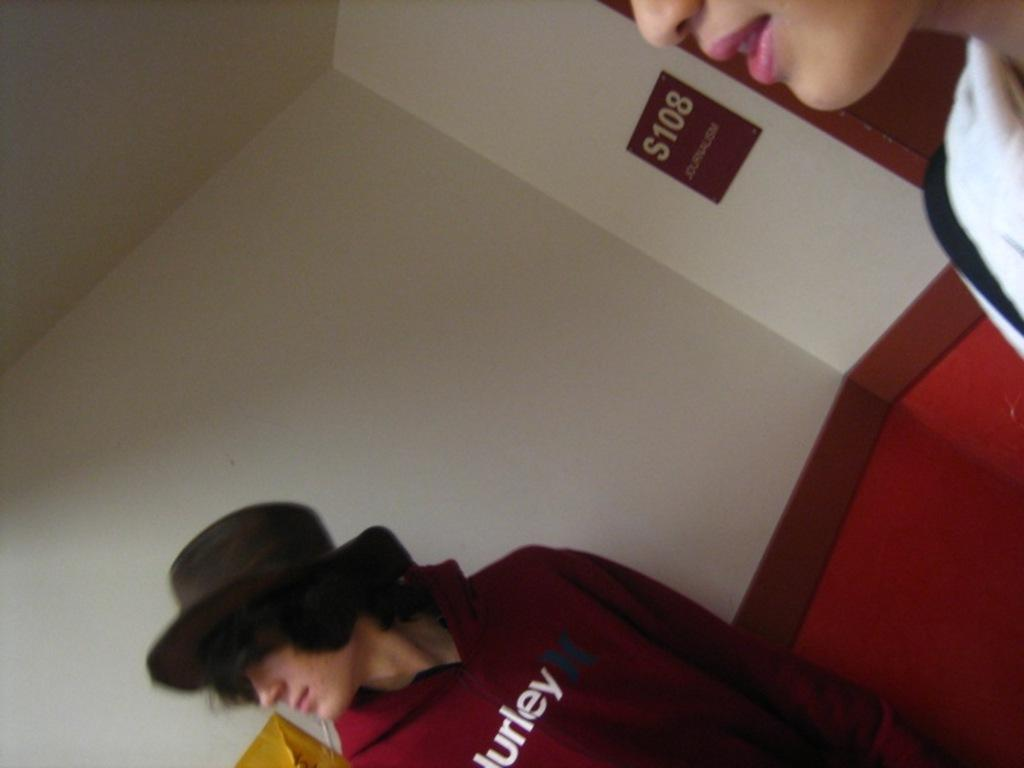How many people are present in the image? There are two people in the image. What can be seen in the background of the image? There is a wall in the background of the image. Is there anything placed on the wall in the background? Yes, there is a board placed on the wall in the background. What type of string is being used by the government in the image? There is no mention of a government or string in the image; it only features two people and a wall with a board on it. 